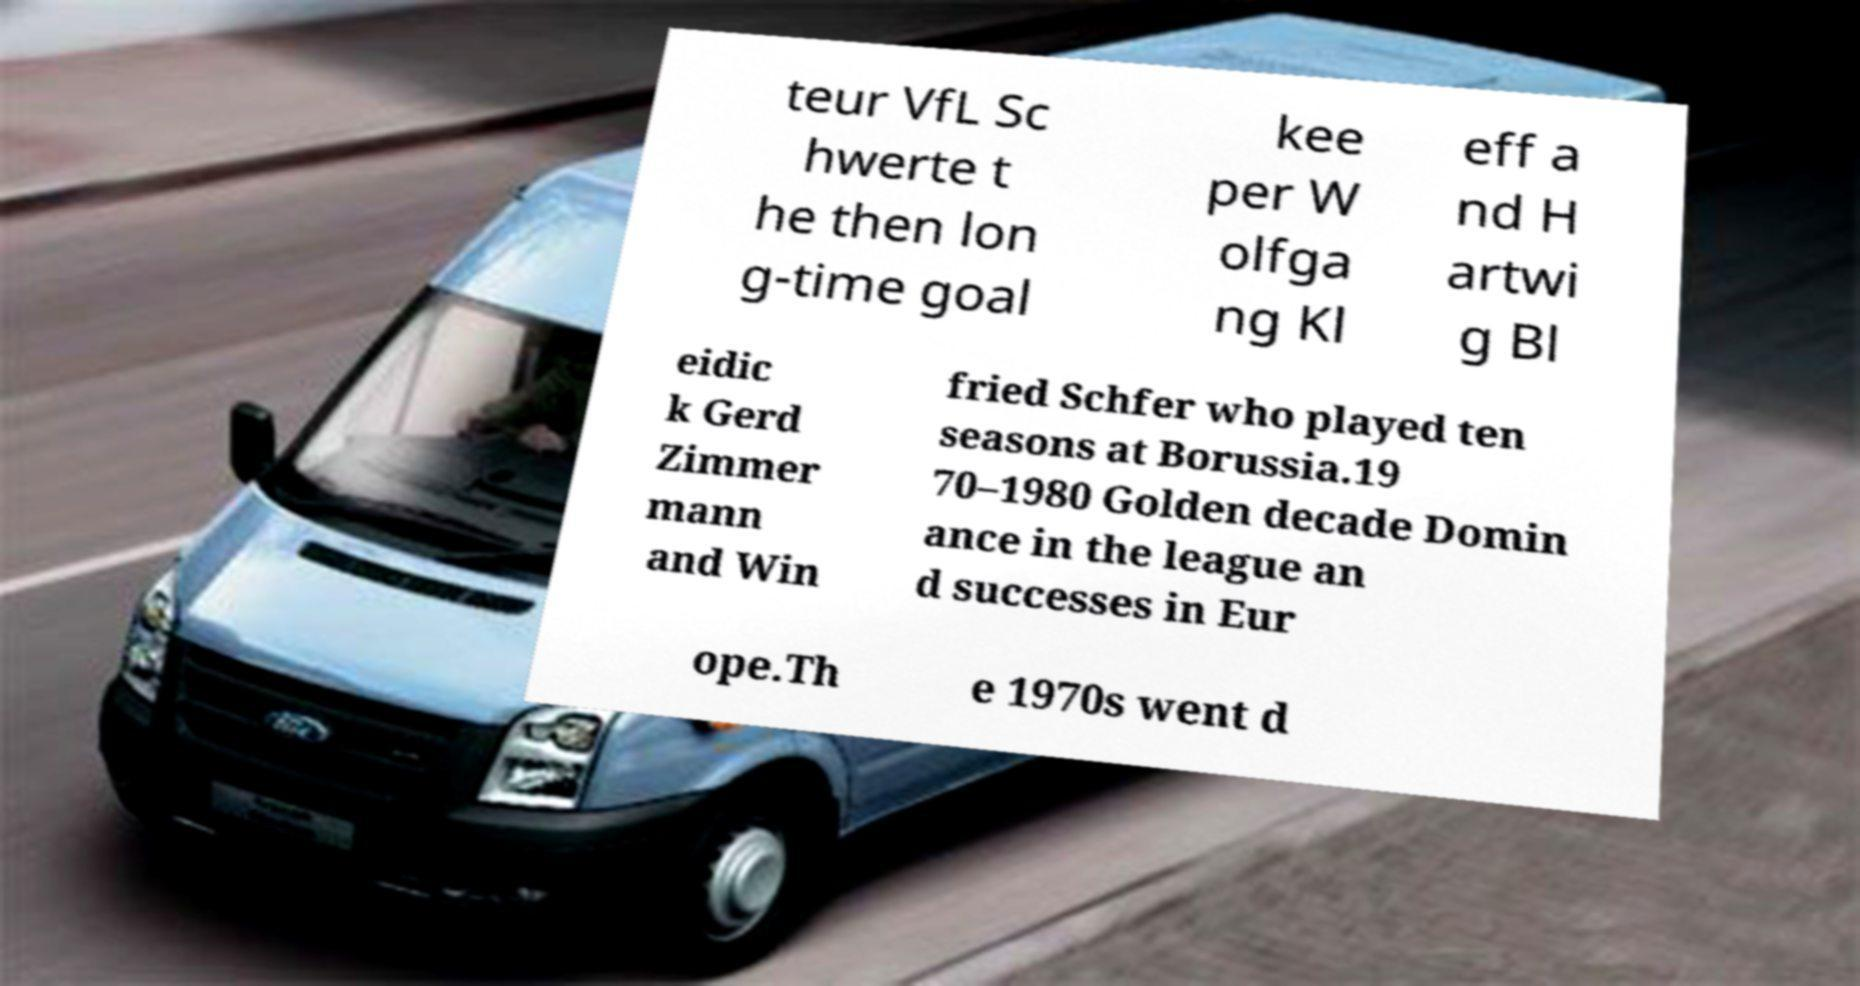There's text embedded in this image that I need extracted. Can you transcribe it verbatim? teur VfL Sc hwerte t he then lon g-time goal kee per W olfga ng Kl eff a nd H artwi g Bl eidic k Gerd Zimmer mann and Win fried Schfer who played ten seasons at Borussia.19 70–1980 Golden decade Domin ance in the league an d successes in Eur ope.Th e 1970s went d 